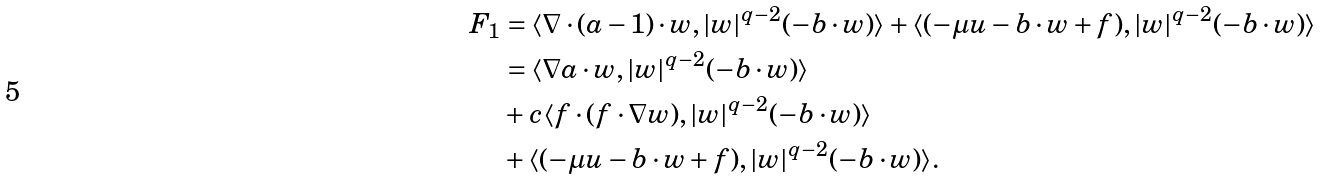<formula> <loc_0><loc_0><loc_500><loc_500>F _ { 1 } & = \langle \nabla \cdot ( a - 1 ) \cdot w , | w | ^ { q - 2 } ( - b \cdot w ) \rangle + \langle ( - \mu u - b \cdot w + f ) , | w | ^ { q - 2 } ( - b \cdot w ) \rangle \\ & = \langle \nabla a \cdot w , | w | ^ { q - 2 } ( - b \cdot w ) \rangle \\ & + c \langle f \cdot ( f \cdot \nabla w ) , | w | ^ { q - 2 } ( - b \cdot w ) \rangle \\ & + \langle ( - \mu u - b \cdot w + f ) , | w | ^ { q - 2 } ( - b \cdot w ) \rangle .</formula> 